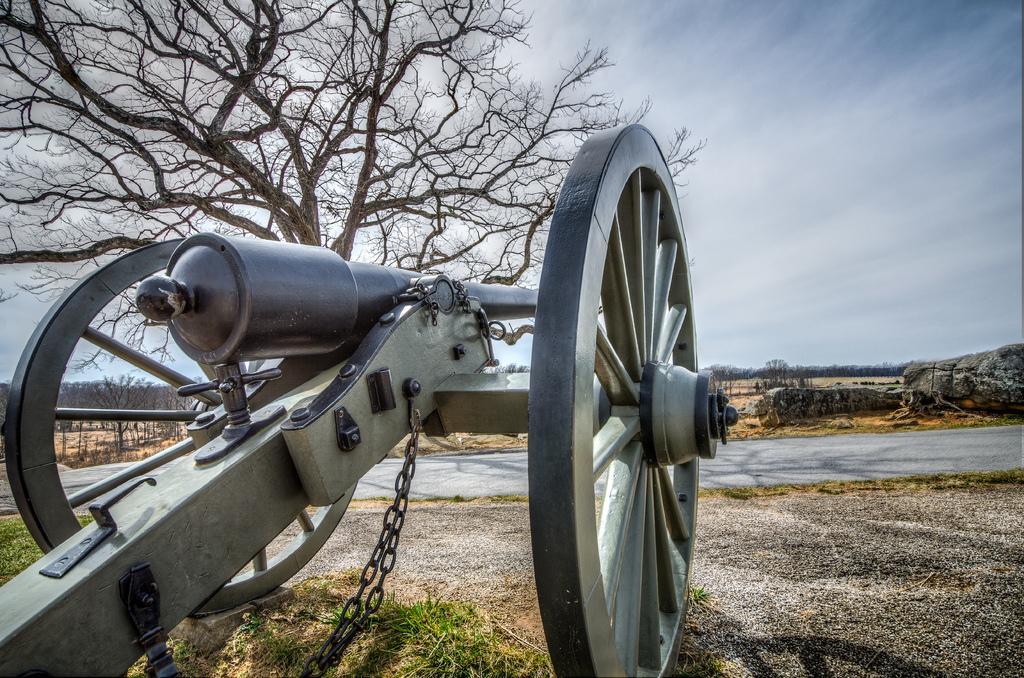Please provide a concise description of this image. This image is taken outdoors. At the top of the image there is the sky with clouds. At the bottom of the image there is a ground with grass on it. In the background there are a few trees on the ground. On the right side of the image there is a rock on the ground. On the left side of the image there is a tree with stems and branches and there is a Cannon on the ground. 